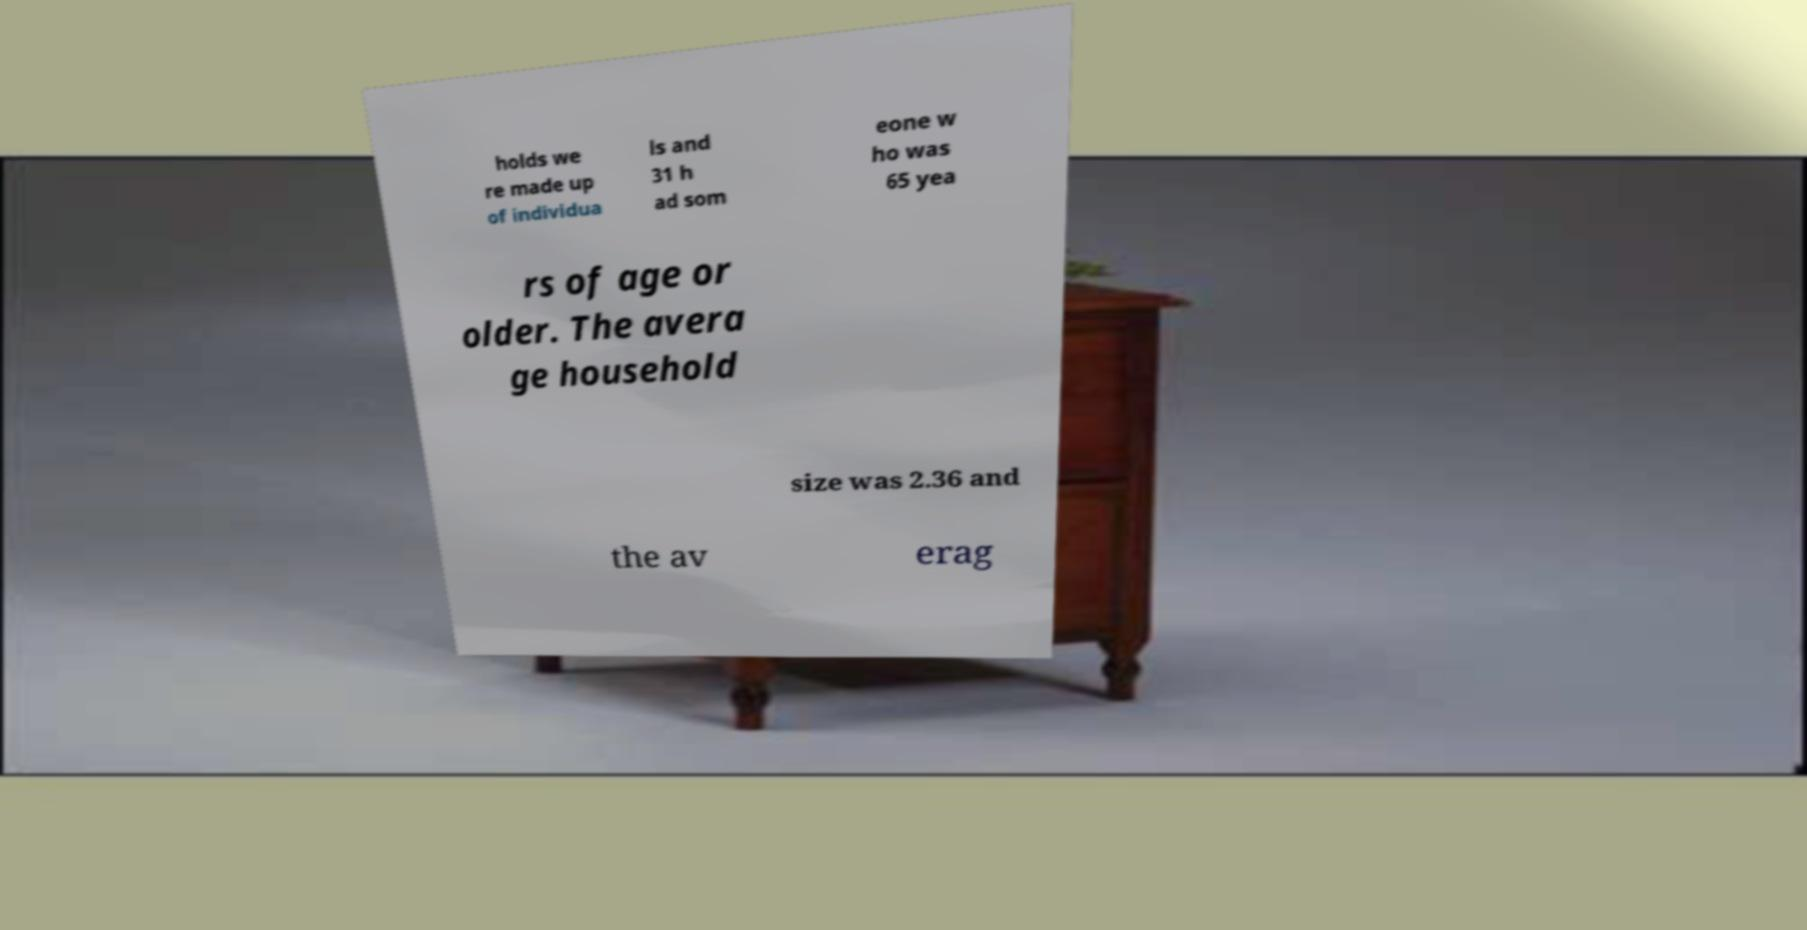There's text embedded in this image that I need extracted. Can you transcribe it verbatim? holds we re made up of individua ls and 31 h ad som eone w ho was 65 yea rs of age or older. The avera ge household size was 2.36 and the av erag 